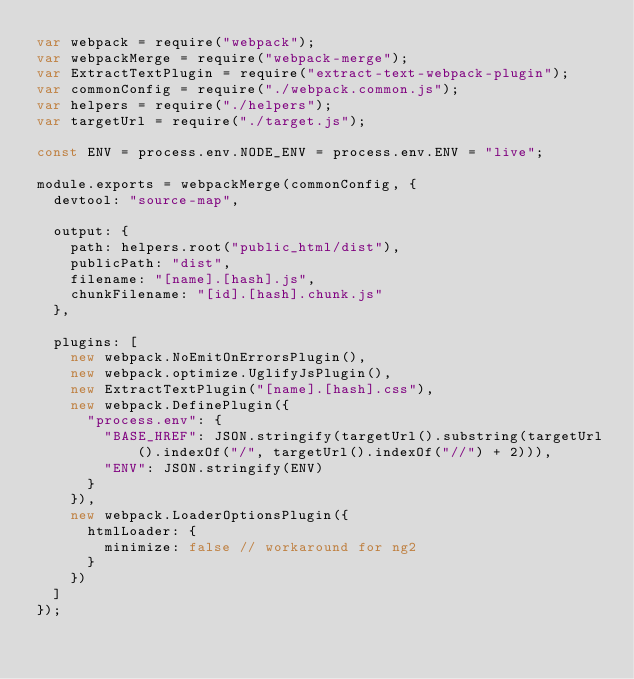<code> <loc_0><loc_0><loc_500><loc_500><_JavaScript_>var webpack = require("webpack");
var webpackMerge = require("webpack-merge");
var ExtractTextPlugin = require("extract-text-webpack-plugin");
var commonConfig = require("./webpack.common.js");
var helpers = require("./helpers");
var targetUrl = require("./target.js");

const ENV = process.env.NODE_ENV = process.env.ENV = "live";

module.exports = webpackMerge(commonConfig, {
	devtool: "source-map",

	output: {
		path: helpers.root("public_html/dist"),
		publicPath: "dist",
		filename: "[name].[hash].js",
		chunkFilename: "[id].[hash].chunk.js"
	},

	plugins: [
		new webpack.NoEmitOnErrorsPlugin(),
		new webpack.optimize.UglifyJsPlugin(),
		new ExtractTextPlugin("[name].[hash].css"),
		new webpack.DefinePlugin({
			"process.env": {
				"BASE_HREF": JSON.stringify(targetUrl().substring(targetUrl().indexOf("/", targetUrl().indexOf("//") + 2))),
				"ENV": JSON.stringify(ENV)
			}
		}),
		new webpack.LoaderOptionsPlugin({
			htmlLoader: {
				minimize: false // workaround for ng2
			}
		})
	]
});</code> 